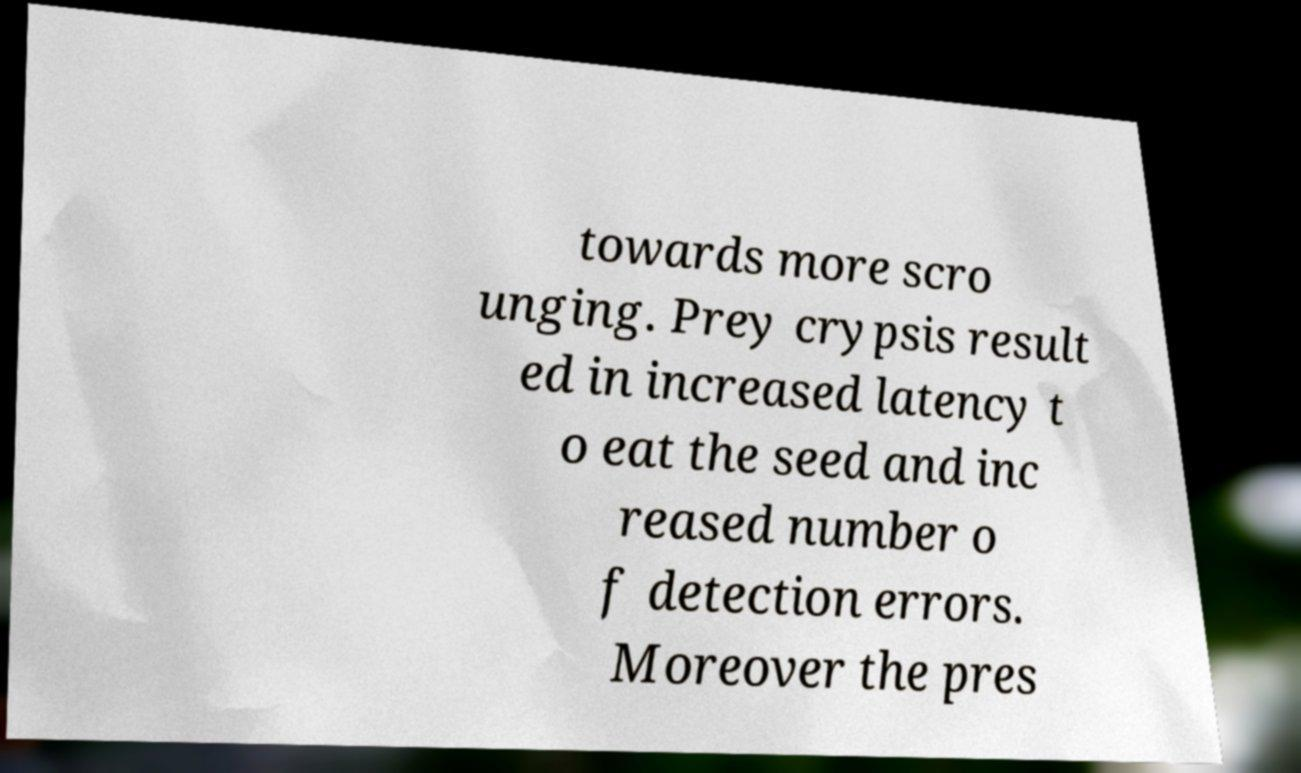Can you read and provide the text displayed in the image?This photo seems to have some interesting text. Can you extract and type it out for me? towards more scro unging. Prey crypsis result ed in increased latency t o eat the seed and inc reased number o f detection errors. Moreover the pres 